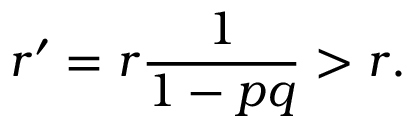Convert formula to latex. <formula><loc_0><loc_0><loc_500><loc_500>r ^ { \prime } = r { \frac { 1 } { 1 - p q } } > r .</formula> 